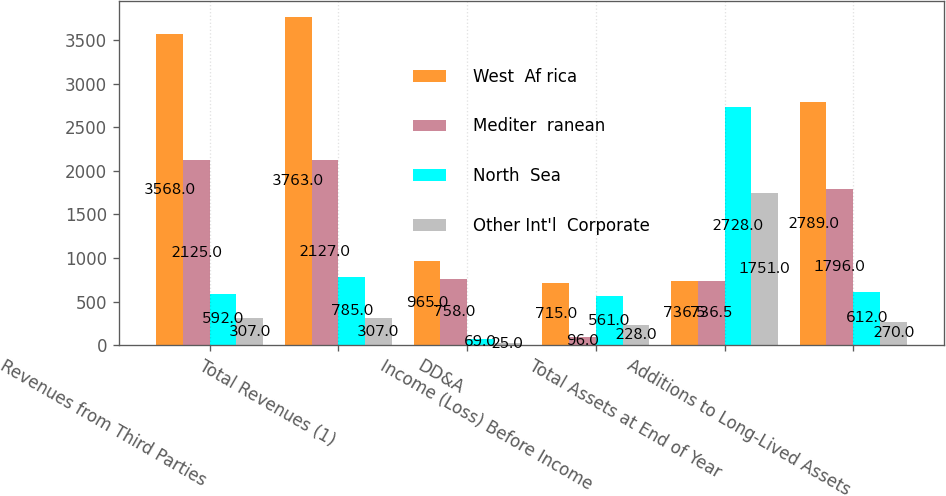Convert chart to OTSL. <chart><loc_0><loc_0><loc_500><loc_500><stacked_bar_chart><ecel><fcel>Revenues from Third Parties<fcel>Total Revenues (1)<fcel>DD&A<fcel>Income (Loss) Before Income<fcel>Total Assets at End of Year<fcel>Additions to Long-Lived Assets<nl><fcel>West  Af rica<fcel>3568<fcel>3763<fcel>965<fcel>715<fcel>736.5<fcel>2789<nl><fcel>Mediter  ranean<fcel>2125<fcel>2127<fcel>758<fcel>96<fcel>736.5<fcel>1796<nl><fcel>North  Sea<fcel>592<fcel>785<fcel>69<fcel>561<fcel>2728<fcel>612<nl><fcel>Other Int'l  Corporate<fcel>307<fcel>307<fcel>25<fcel>228<fcel>1751<fcel>270<nl></chart> 